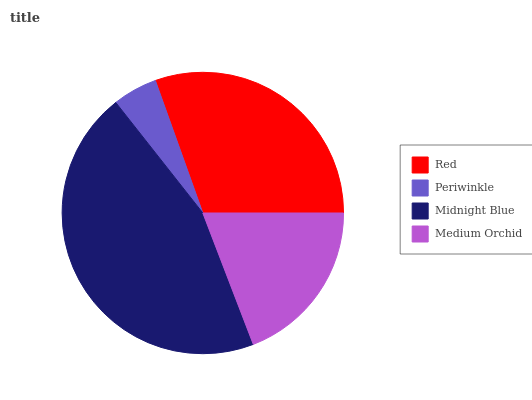Is Periwinkle the minimum?
Answer yes or no. Yes. Is Midnight Blue the maximum?
Answer yes or no. Yes. Is Midnight Blue the minimum?
Answer yes or no. No. Is Periwinkle the maximum?
Answer yes or no. No. Is Midnight Blue greater than Periwinkle?
Answer yes or no. Yes. Is Periwinkle less than Midnight Blue?
Answer yes or no. Yes. Is Periwinkle greater than Midnight Blue?
Answer yes or no. No. Is Midnight Blue less than Periwinkle?
Answer yes or no. No. Is Red the high median?
Answer yes or no. Yes. Is Medium Orchid the low median?
Answer yes or no. Yes. Is Periwinkle the high median?
Answer yes or no. No. Is Red the low median?
Answer yes or no. No. 